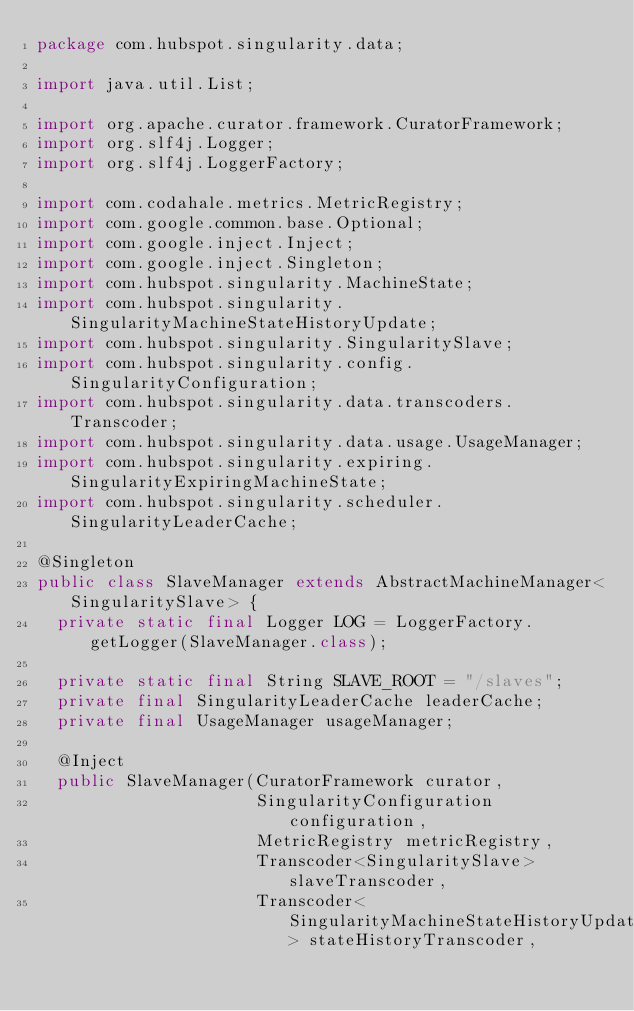<code> <loc_0><loc_0><loc_500><loc_500><_Java_>package com.hubspot.singularity.data;

import java.util.List;

import org.apache.curator.framework.CuratorFramework;
import org.slf4j.Logger;
import org.slf4j.LoggerFactory;

import com.codahale.metrics.MetricRegistry;
import com.google.common.base.Optional;
import com.google.inject.Inject;
import com.google.inject.Singleton;
import com.hubspot.singularity.MachineState;
import com.hubspot.singularity.SingularityMachineStateHistoryUpdate;
import com.hubspot.singularity.SingularitySlave;
import com.hubspot.singularity.config.SingularityConfiguration;
import com.hubspot.singularity.data.transcoders.Transcoder;
import com.hubspot.singularity.data.usage.UsageManager;
import com.hubspot.singularity.expiring.SingularityExpiringMachineState;
import com.hubspot.singularity.scheduler.SingularityLeaderCache;

@Singleton
public class SlaveManager extends AbstractMachineManager<SingularitySlave> {
  private static final Logger LOG = LoggerFactory.getLogger(SlaveManager.class);

  private static final String SLAVE_ROOT = "/slaves";
  private final SingularityLeaderCache leaderCache;
  private final UsageManager usageManager;

  @Inject
  public SlaveManager(CuratorFramework curator,
                      SingularityConfiguration configuration,
                      MetricRegistry metricRegistry,
                      Transcoder<SingularitySlave> slaveTranscoder,
                      Transcoder<SingularityMachineStateHistoryUpdate> stateHistoryTranscoder,</code> 